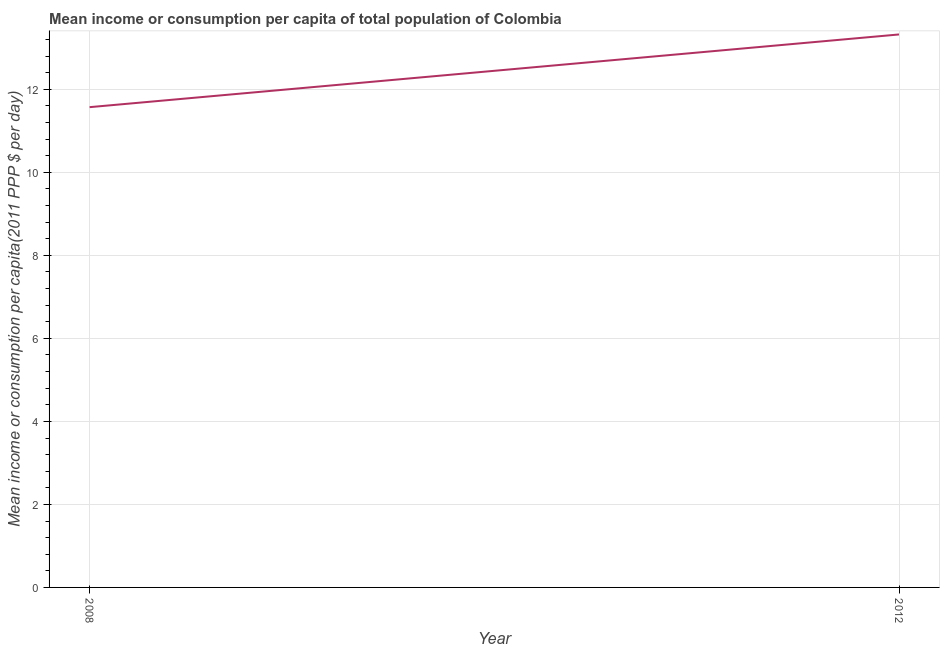What is the mean income or consumption in 2008?
Your answer should be very brief. 11.57. Across all years, what is the maximum mean income or consumption?
Your answer should be very brief. 13.32. Across all years, what is the minimum mean income or consumption?
Make the answer very short. 11.57. In which year was the mean income or consumption maximum?
Provide a short and direct response. 2012. What is the sum of the mean income or consumption?
Give a very brief answer. 24.89. What is the difference between the mean income or consumption in 2008 and 2012?
Offer a terse response. -1.75. What is the average mean income or consumption per year?
Provide a succinct answer. 12.45. What is the median mean income or consumption?
Your answer should be very brief. 12.45. What is the ratio of the mean income or consumption in 2008 to that in 2012?
Your response must be concise. 0.87. Is the mean income or consumption in 2008 less than that in 2012?
Offer a very short reply. Yes. Does the mean income or consumption monotonically increase over the years?
Provide a short and direct response. Yes. How many years are there in the graph?
Give a very brief answer. 2. Are the values on the major ticks of Y-axis written in scientific E-notation?
Your answer should be very brief. No. Does the graph contain any zero values?
Offer a very short reply. No. Does the graph contain grids?
Make the answer very short. Yes. What is the title of the graph?
Provide a succinct answer. Mean income or consumption per capita of total population of Colombia. What is the label or title of the Y-axis?
Keep it short and to the point. Mean income or consumption per capita(2011 PPP $ per day). What is the Mean income or consumption per capita(2011 PPP $ per day) of 2008?
Your response must be concise. 11.57. What is the Mean income or consumption per capita(2011 PPP $ per day) of 2012?
Offer a terse response. 13.32. What is the difference between the Mean income or consumption per capita(2011 PPP $ per day) in 2008 and 2012?
Give a very brief answer. -1.75. What is the ratio of the Mean income or consumption per capita(2011 PPP $ per day) in 2008 to that in 2012?
Give a very brief answer. 0.87. 